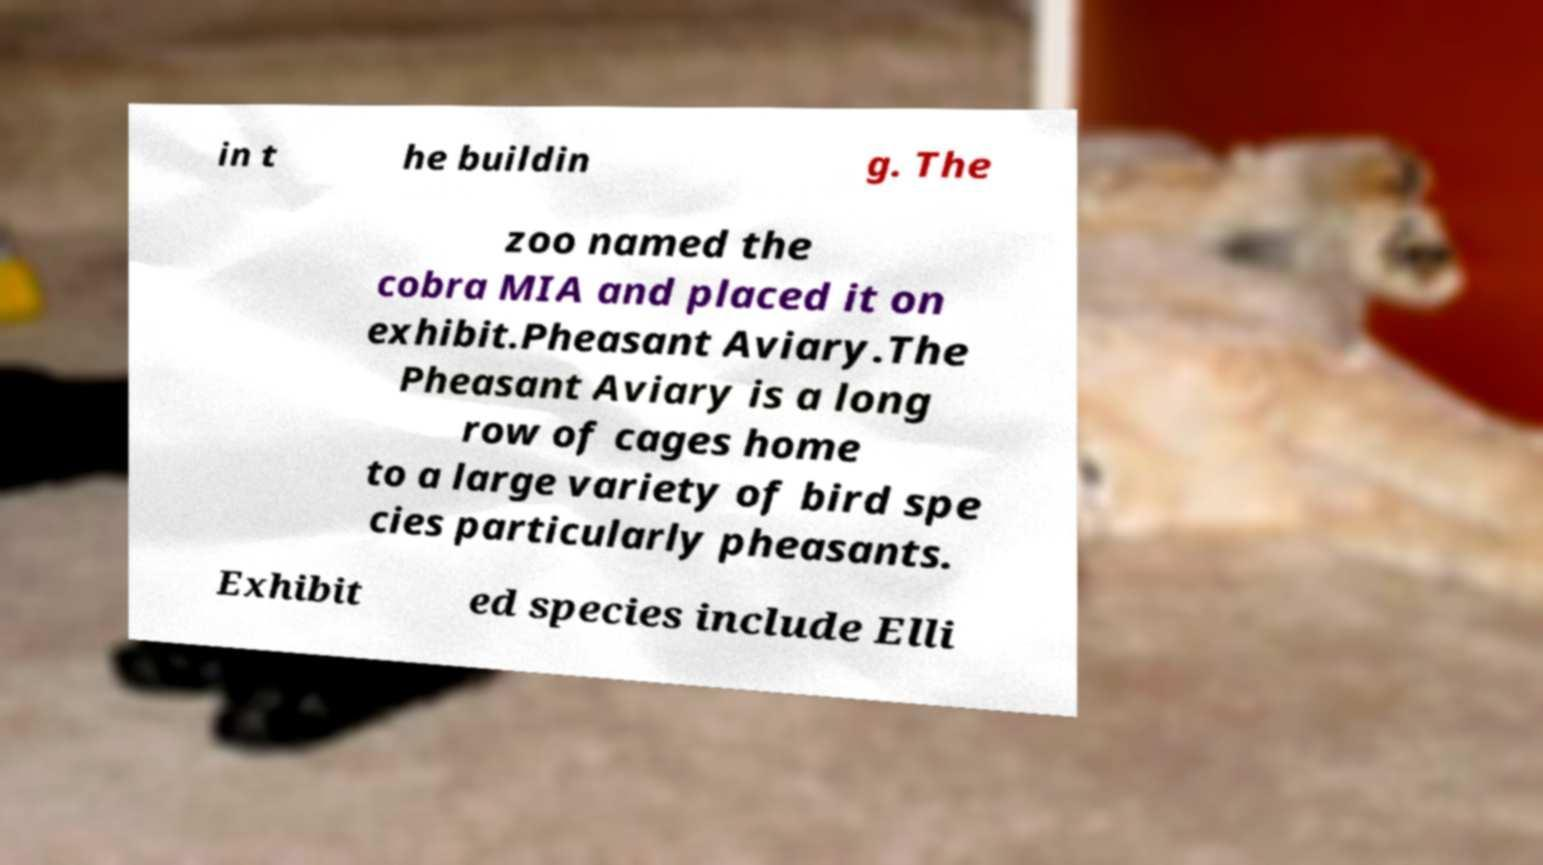Could you extract and type out the text from this image? in t he buildin g. The zoo named the cobra MIA and placed it on exhibit.Pheasant Aviary.The Pheasant Aviary is a long row of cages home to a large variety of bird spe cies particularly pheasants. Exhibit ed species include Elli 